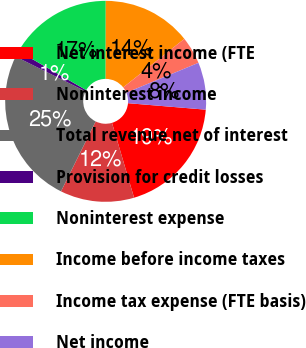<chart> <loc_0><loc_0><loc_500><loc_500><pie_chart><fcel>Net interest income (FTE<fcel>Noninterest income<fcel>Total revenue net of interest<fcel>Provision for credit losses<fcel>Noninterest expense<fcel>Income before income taxes<fcel>Income tax expense (FTE basis)<fcel>Net income<nl><fcel>19.11%<fcel>11.89%<fcel>25.02%<fcel>0.97%<fcel>16.7%<fcel>14.3%<fcel>4.42%<fcel>7.58%<nl></chart> 